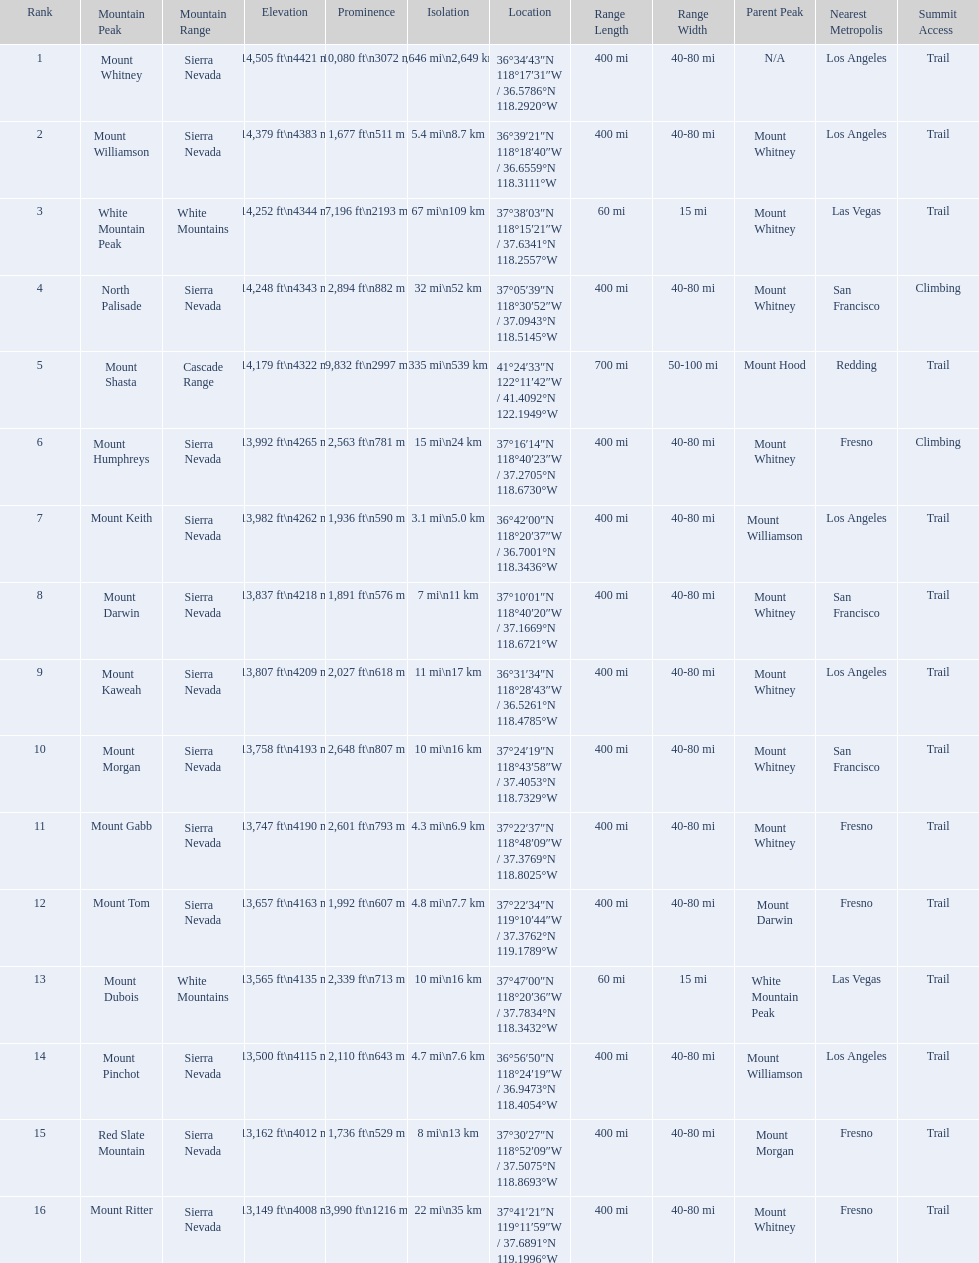What are the prominence lengths higher than 10,000 feet? 10,080 ft\n3072 m. What mountain peak has a prominence of 10,080 feet? Mount Whitney. 